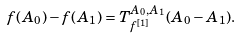<formula> <loc_0><loc_0><loc_500><loc_500>f ( A _ { 0 } ) - f ( A _ { 1 } ) = T ^ { A _ { 0 } , A _ { 1 } } _ { f ^ { [ 1 ] } } ( A _ { 0 } - A _ { 1 } ) .</formula> 